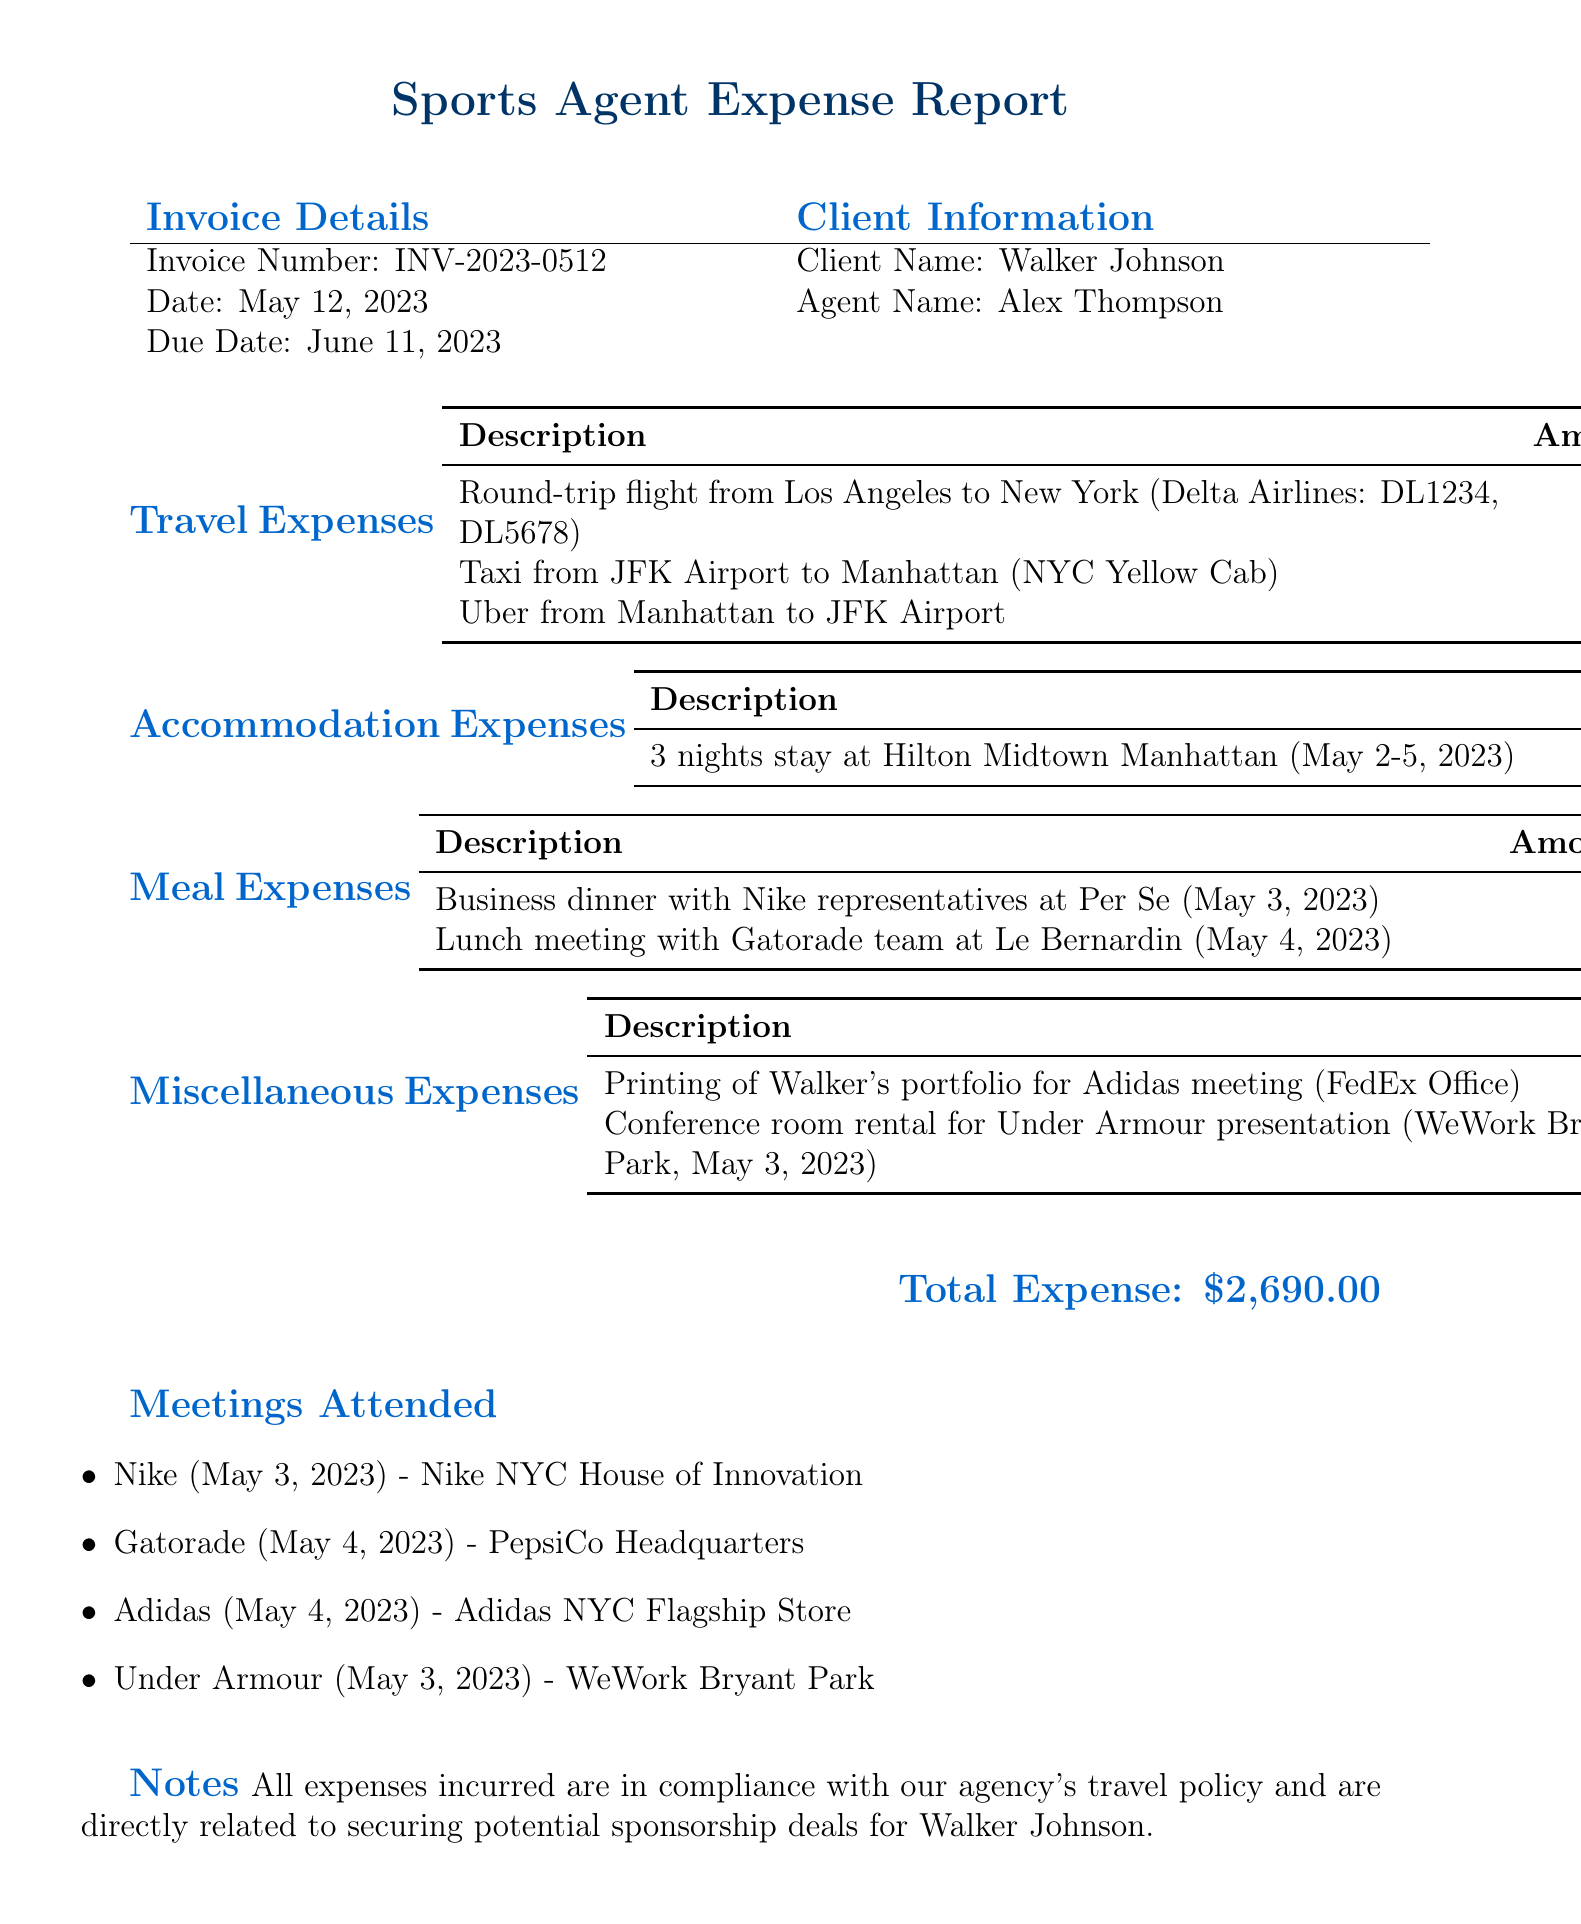What is the invoice number? The invoice number is mentioned in the document under invoice details.
Answer: INV-2023-0512 Who is the client name? The client's name is listed in the invoice details section.
Answer: Walker Johnson What is the total expense? The total expense is stated towards the end of the document as a summary.
Answer: $2,690.00 How many nights did Walker stay at the hotel? The accommodation expense details how many nights were booked for the stay.
Answer: 3 nights Which airline was used for the round-trip flight? The travel expense section specifies the airline for the flight.
Answer: Delta Airlines What date was the business dinner with Nike representatives? The meal expense section includes the date of the dinner meeting.
Answer: May 3, 2023 Where was the Gatorade lunch meeting held? The meal expense section lists the location of the lunch meeting.
Answer: Le Bernardin What is the check-out date for the hotel stay? The accommodation expenses detail the check-out date for the stay.
Answer: May 5, 2023 What was the reason stated for incurring these expenses? The notes section provides the reason for the expenses.
Answer: Securing potential sponsorship deals for Walker Johnson 